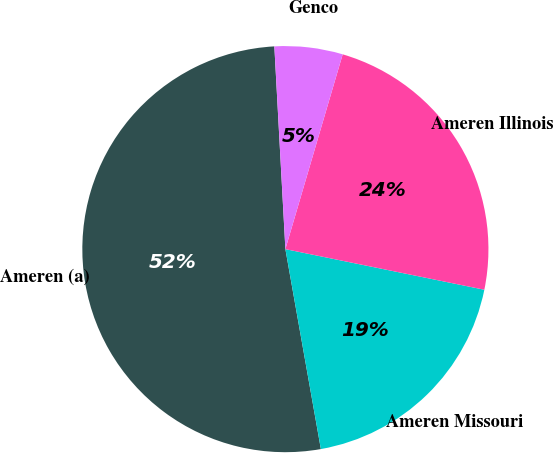Convert chart. <chart><loc_0><loc_0><loc_500><loc_500><pie_chart><fcel>Ameren (a)<fcel>Ameren Missouri<fcel>Ameren Illinois<fcel>Genco<nl><fcel>51.93%<fcel>19.0%<fcel>23.65%<fcel>5.42%<nl></chart> 